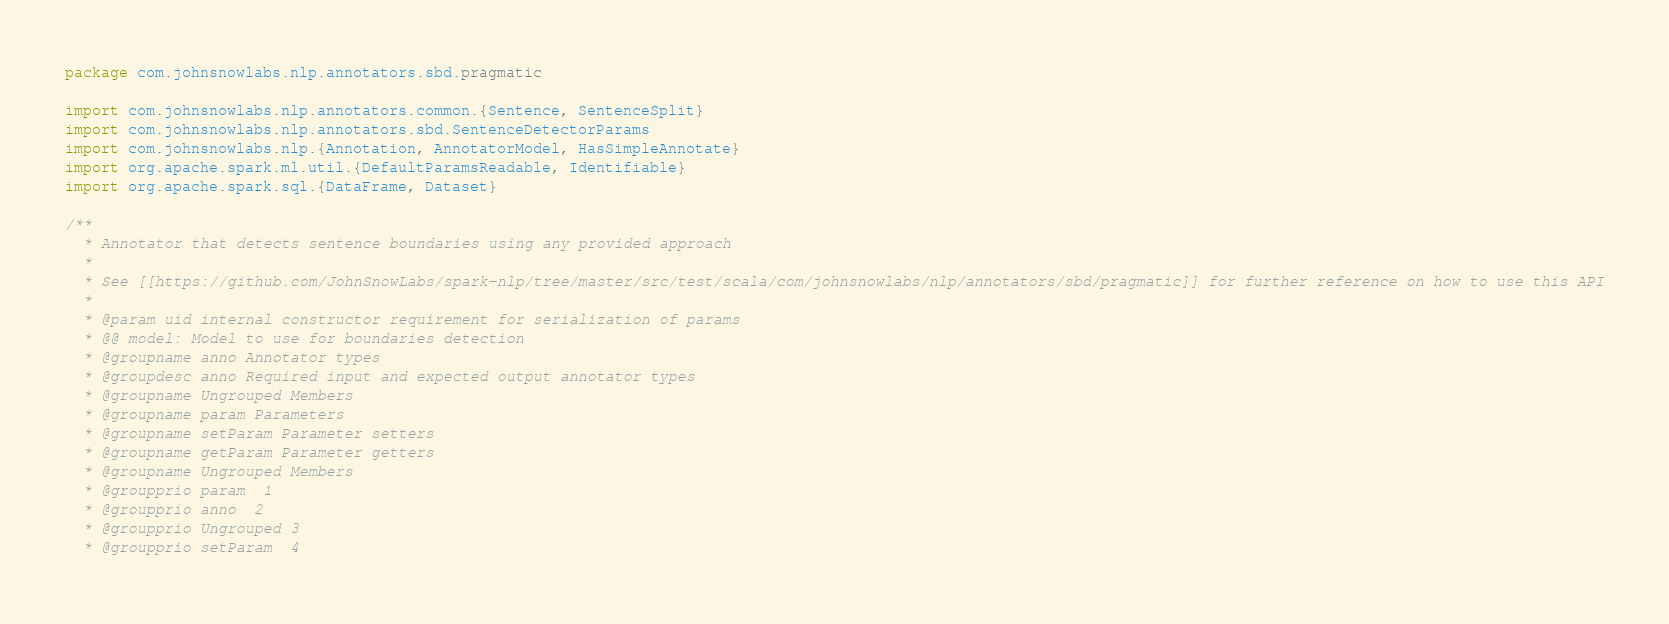Convert code to text. <code><loc_0><loc_0><loc_500><loc_500><_Scala_>package com.johnsnowlabs.nlp.annotators.sbd.pragmatic

import com.johnsnowlabs.nlp.annotators.common.{Sentence, SentenceSplit}
import com.johnsnowlabs.nlp.annotators.sbd.SentenceDetectorParams
import com.johnsnowlabs.nlp.{Annotation, AnnotatorModel, HasSimpleAnnotate}
import org.apache.spark.ml.util.{DefaultParamsReadable, Identifiable}
import org.apache.spark.sql.{DataFrame, Dataset}

/**
  * Annotator that detects sentence boundaries using any provided approach
  *
  * See [[https://github.com/JohnSnowLabs/spark-nlp/tree/master/src/test/scala/com/johnsnowlabs/nlp/annotators/sbd/pragmatic]] for further reference on how to use this API
  *
  * @param uid internal constructor requirement for serialization of params
  * @@ model: Model to use for boundaries detection
  * @groupname anno Annotator types
  * @groupdesc anno Required input and expected output annotator types
  * @groupname Ungrouped Members
  * @groupname param Parameters
  * @groupname setParam Parameter setters
  * @groupname getParam Parameter getters
  * @groupname Ungrouped Members
  * @groupprio param  1
  * @groupprio anno  2
  * @groupprio Ungrouped 3
  * @groupprio setParam  4</code> 